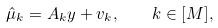Convert formula to latex. <formula><loc_0><loc_0><loc_500><loc_500>\hat { \mu } _ { k } = A _ { k } y + v _ { k } , \quad k \in [ M ] ,</formula> 